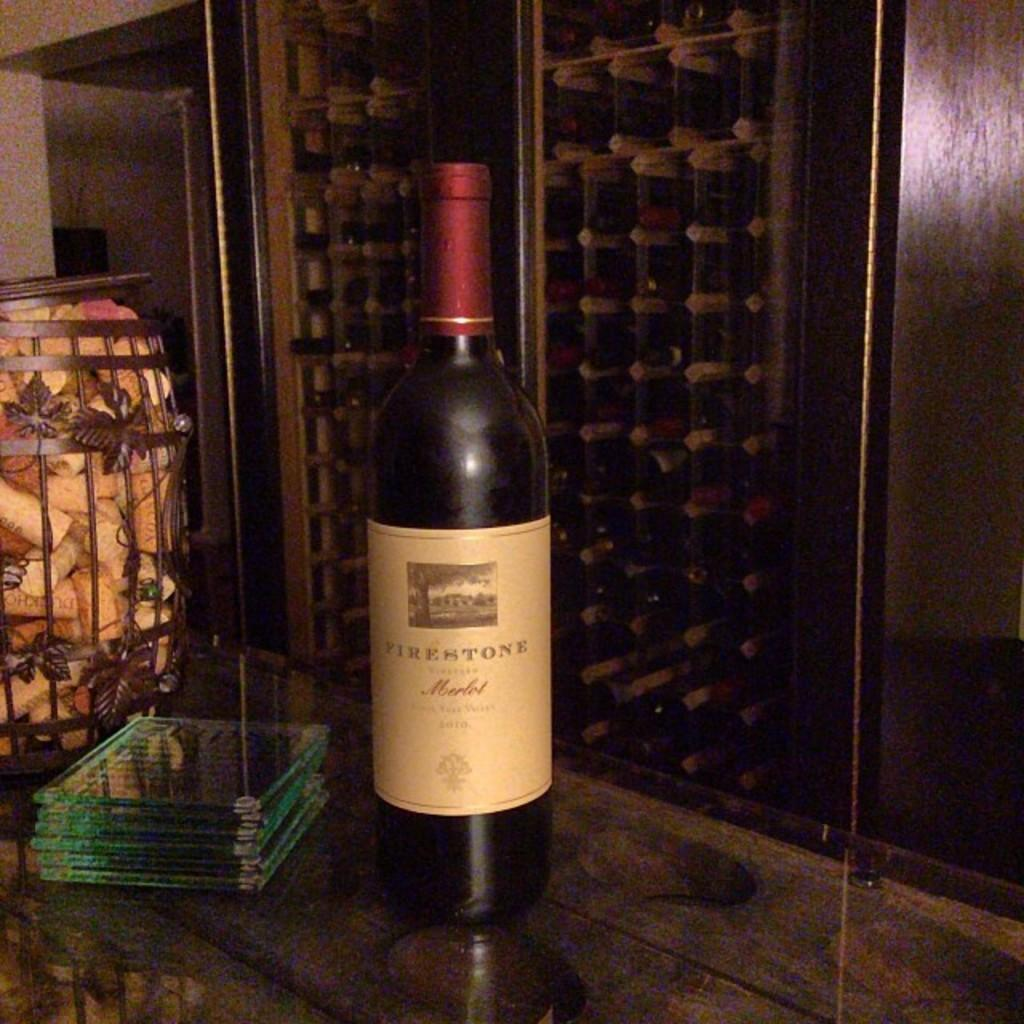What is the color of the cap on the bottle in the image? The cap on the bottle in the image is red. Where is the bottle located in the image? The bottle is on a table in the image. What is present in the basket in the image? There is a basket of corks in the image. What type of materials can be seen on the table in the image? There are glass materials on the table in the image. What is located behind the table in the image? There is a bar cabinet behind the table in the image. How many cows are visible in the image? There are no cows present in the image. 